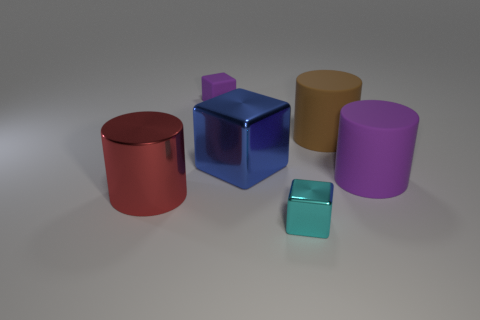Subtract all purple matte blocks. How many blocks are left? 2 Add 1 purple rubber cylinders. How many objects exist? 7 Subtract all cyan blocks. How many blocks are left? 2 Subtract 1 red cylinders. How many objects are left? 5 Subtract 1 blocks. How many blocks are left? 2 Subtract all purple blocks. Subtract all cyan cylinders. How many blocks are left? 2 Subtract all yellow cylinders. How many purple blocks are left? 1 Subtract all purple rubber cubes. Subtract all purple rubber things. How many objects are left? 3 Add 4 big red metal things. How many big red metal things are left? 5 Add 4 large purple matte cylinders. How many large purple matte cylinders exist? 5 